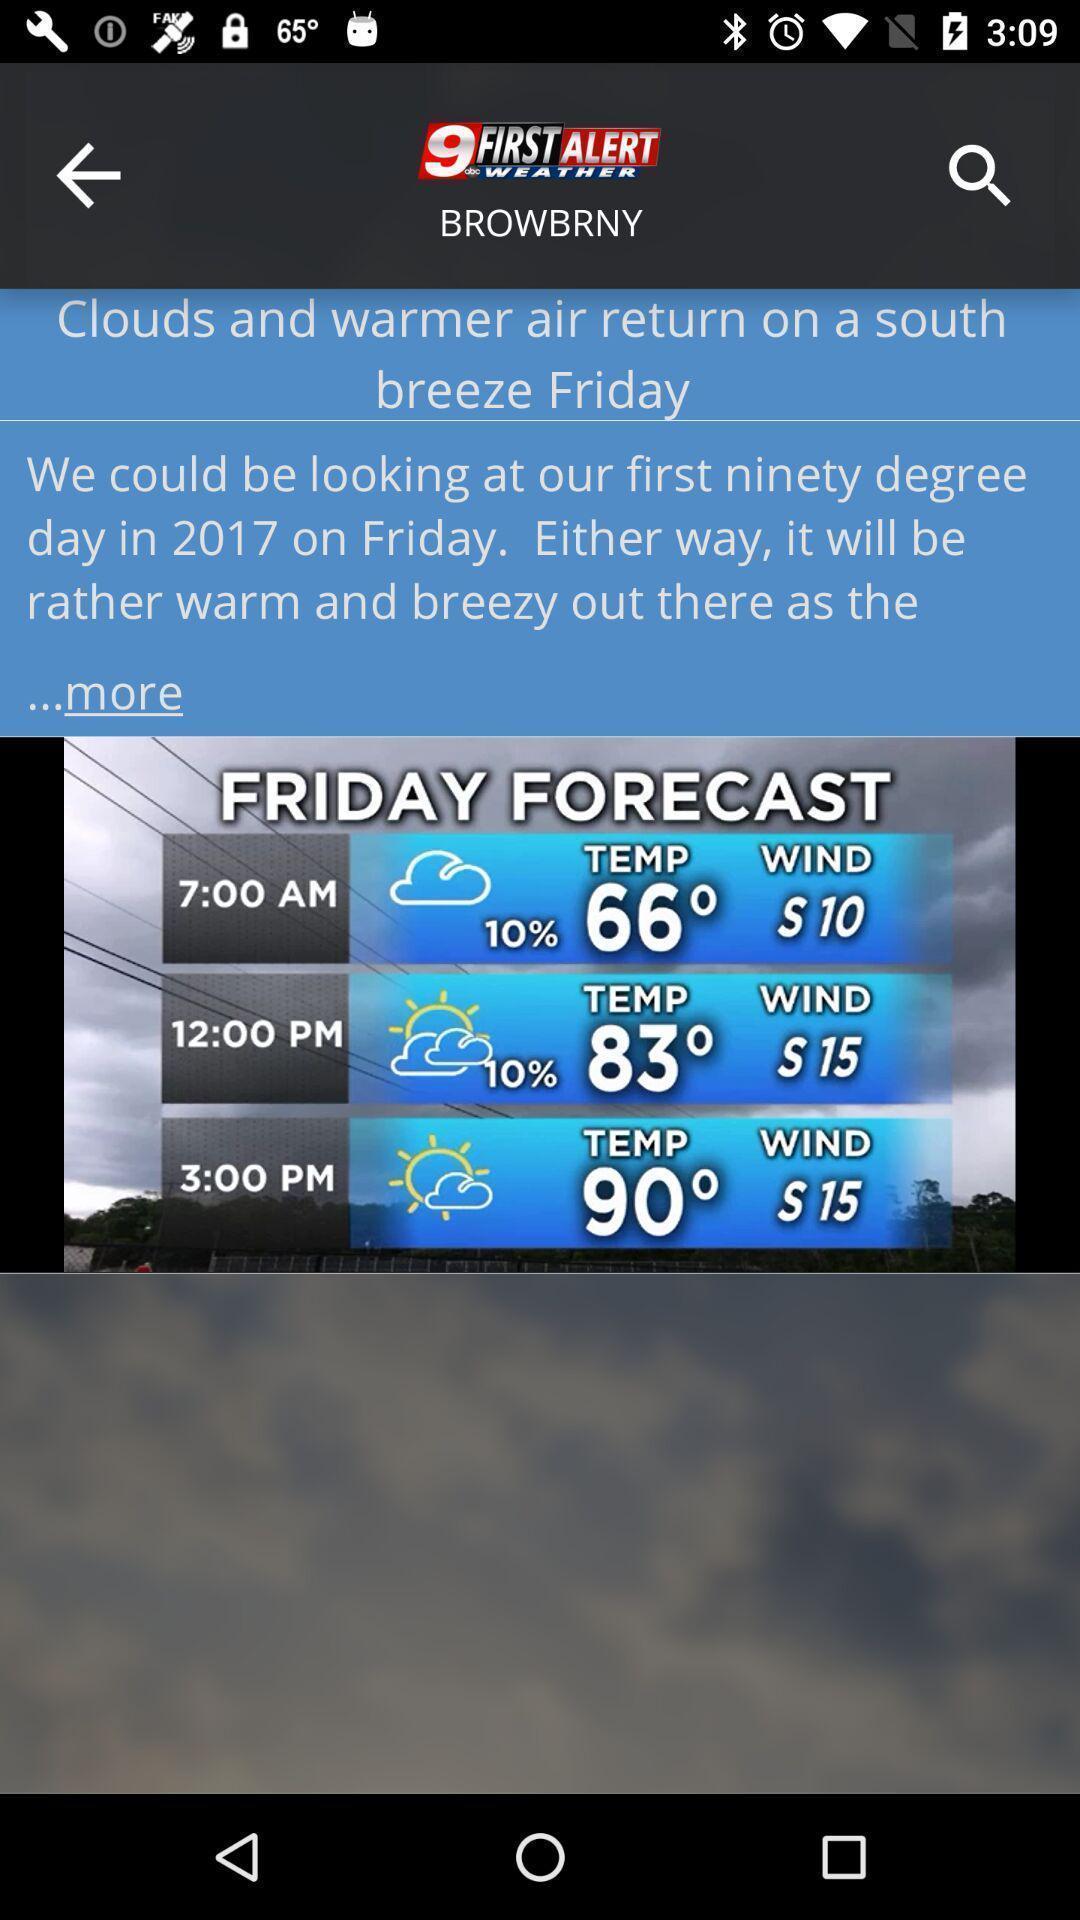Please provide a description for this image. Screen displaying information of a weather application. 